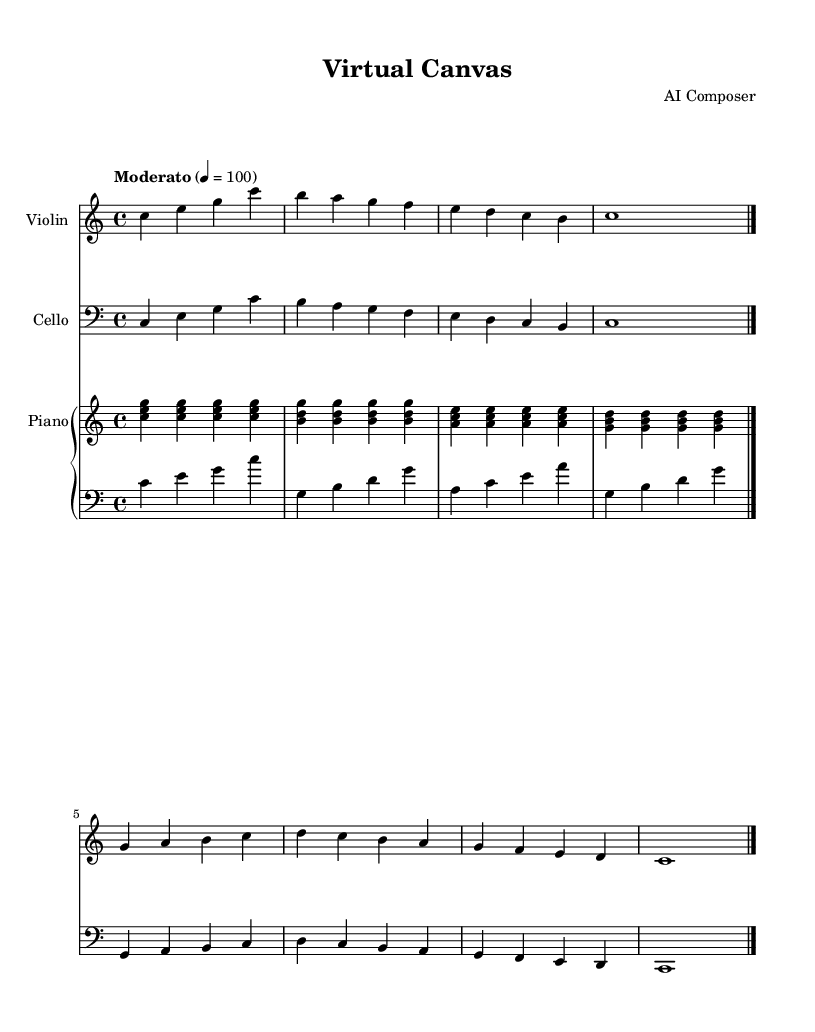What is the key signature of this music? The key signature is C major, which has no sharps or flats.
Answer: C major What is the time signature of this piece? The time signature is indicated as 4/4, meaning there are four beats per measure.
Answer: 4/4 What is the tempo marking for this piece? The tempo marking is "Moderato," which is a moderate pace indicated at quarter note equal to 100 beats per minute.
Answer: Moderato How many measures are there in the violin part? The violin part contains four measures, with each measure marked clearly by bar lines.
Answer: 4 What is the highest note in the cello part? The highest note in the cello part is C in the fourth octave, which can be identified by looking at the note heads in the notation.
Answer: C In terms of dynamics, what instruction is given for this score? The score lacks explicit dynamic markings, implying a softer dynamic throughout, typical for contemporary classical works emphasizing texture over dynamics.
Answer: None What instruments are featured in this piece? The piece features the violin, cello, and piano, indicated by the staves labeled with their respective instrument names at the beginning.
Answer: Violin, Cello, Piano 